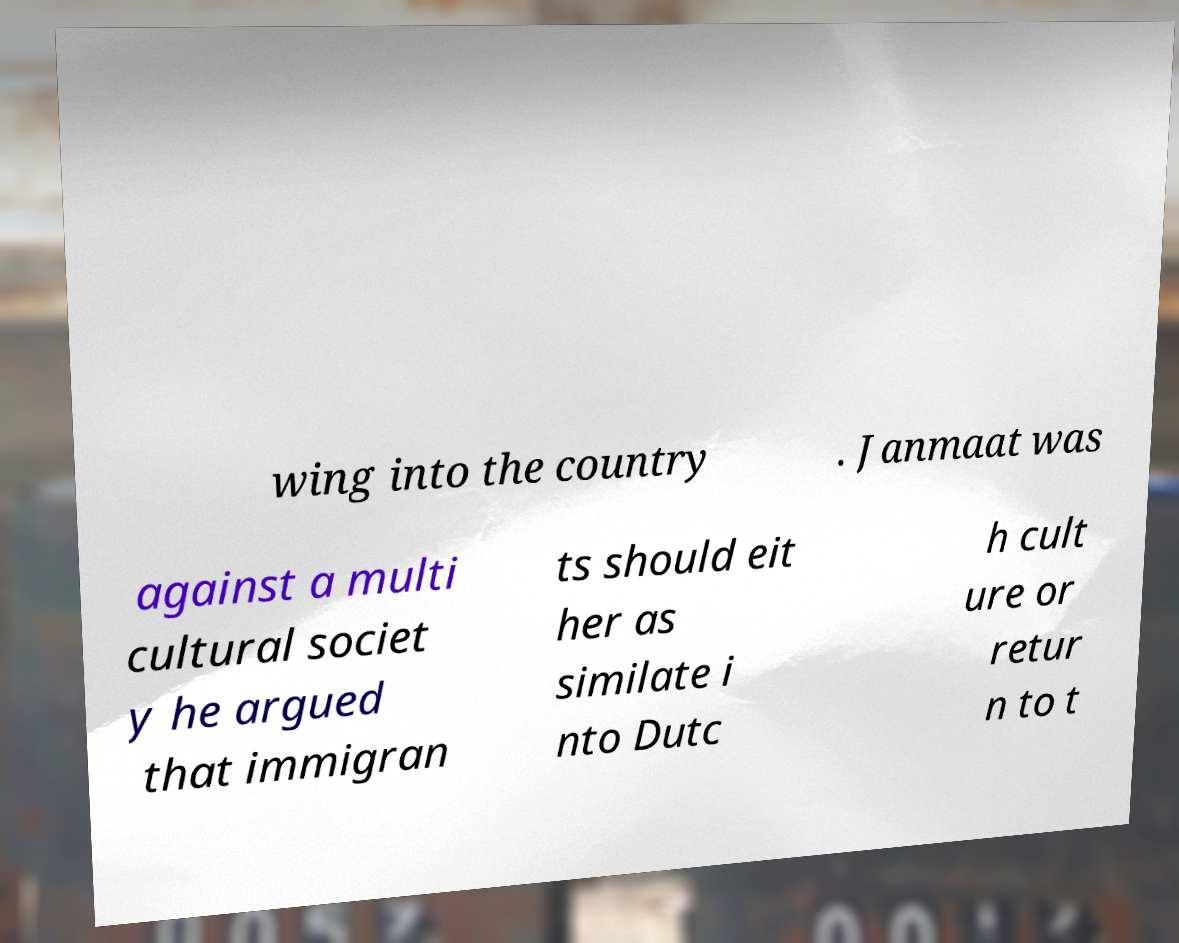Can you read and provide the text displayed in the image?This photo seems to have some interesting text. Can you extract and type it out for me? wing into the country . Janmaat was against a multi cultural societ y he argued that immigran ts should eit her as similate i nto Dutc h cult ure or retur n to t 